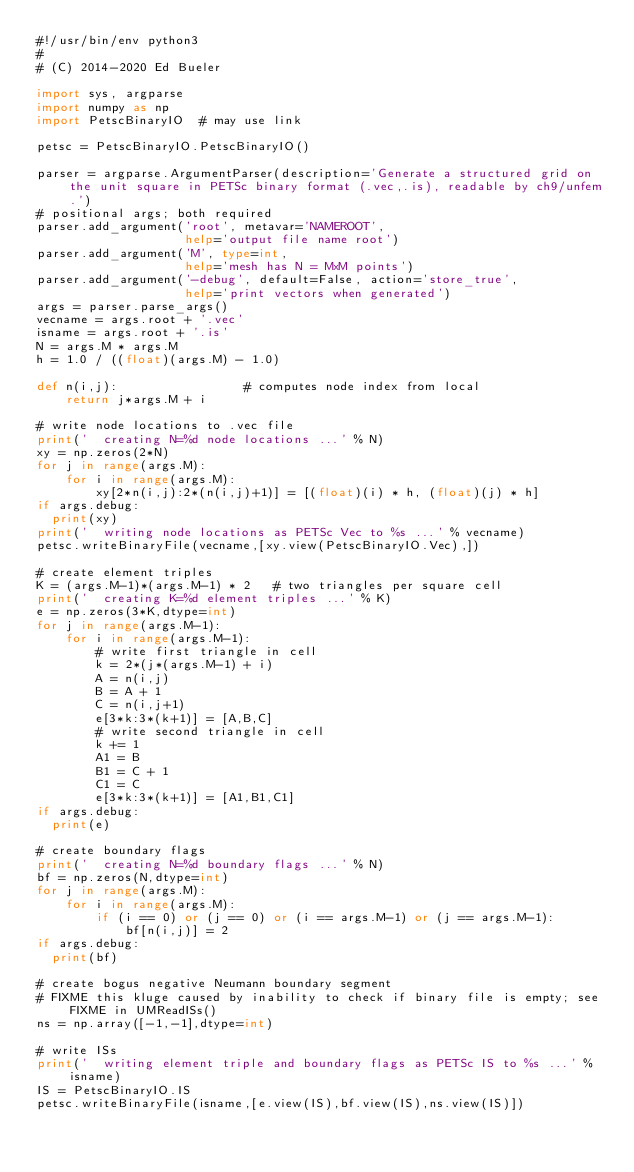<code> <loc_0><loc_0><loc_500><loc_500><_Python_>#!/usr/bin/env python3
#
# (C) 2014-2020 Ed Bueler

import sys, argparse
import numpy as np
import PetscBinaryIO  # may use link

petsc = PetscBinaryIO.PetscBinaryIO()

parser = argparse.ArgumentParser(description='Generate a structured grid on the unit square in PETSc binary format (.vec,.is), readable by ch9/unfem.')
# positional args; both required
parser.add_argument('root', metavar='NAMEROOT',
                    help='output file name root')
parser.add_argument('M', type=int,
                    help='mesh has N = MxM points')
parser.add_argument('-debug', default=False, action='store_true',
                    help='print vectors when generated')
args = parser.parse_args()
vecname = args.root + '.vec'
isname = args.root + '.is'
N = args.M * args.M
h = 1.0 / ((float)(args.M) - 1.0)

def n(i,j):                 # computes node index from local
    return j*args.M + i

# write node locations to .vec file
print('  creating N=%d node locations ...' % N)
xy = np.zeros(2*N)
for j in range(args.M):
    for i in range(args.M):
        xy[2*n(i,j):2*(n(i,j)+1)] = [(float)(i) * h, (float)(j) * h]
if args.debug:
  print(xy)
print('  writing node locations as PETSc Vec to %s ...' % vecname)
petsc.writeBinaryFile(vecname,[xy.view(PetscBinaryIO.Vec),])

# create element triples
K = (args.M-1)*(args.M-1) * 2   # two triangles per square cell
print('  creating K=%d element triples ...' % K)
e = np.zeros(3*K,dtype=int)
for j in range(args.M-1):
    for i in range(args.M-1):
        # write first triangle in cell
        k = 2*(j*(args.M-1) + i)
        A = n(i,j)
        B = A + 1
        C = n(i,j+1)
        e[3*k:3*(k+1)] = [A,B,C]
        # write second triangle in cell
        k += 1
        A1 = B
        B1 = C + 1
        C1 = C
        e[3*k:3*(k+1)] = [A1,B1,C1]
if args.debug:
  print(e)

# create boundary flags
print('  creating N=%d boundary flags ...' % N)
bf = np.zeros(N,dtype=int)
for j in range(args.M):
    for i in range(args.M):
        if (i == 0) or (j == 0) or (i == args.M-1) or (j == args.M-1):
            bf[n(i,j)] = 2
if args.debug:
  print(bf)

# create bogus negative Neumann boundary segment
# FIXME this kluge caused by inability to check if binary file is empty; see FIXME in UMReadISs()
ns = np.array([-1,-1],dtype=int)

# write ISs
print('  writing element triple and boundary flags as PETSc IS to %s ...' % isname)
IS = PetscBinaryIO.IS
petsc.writeBinaryFile(isname,[e.view(IS),bf.view(IS),ns.view(IS)])

</code> 